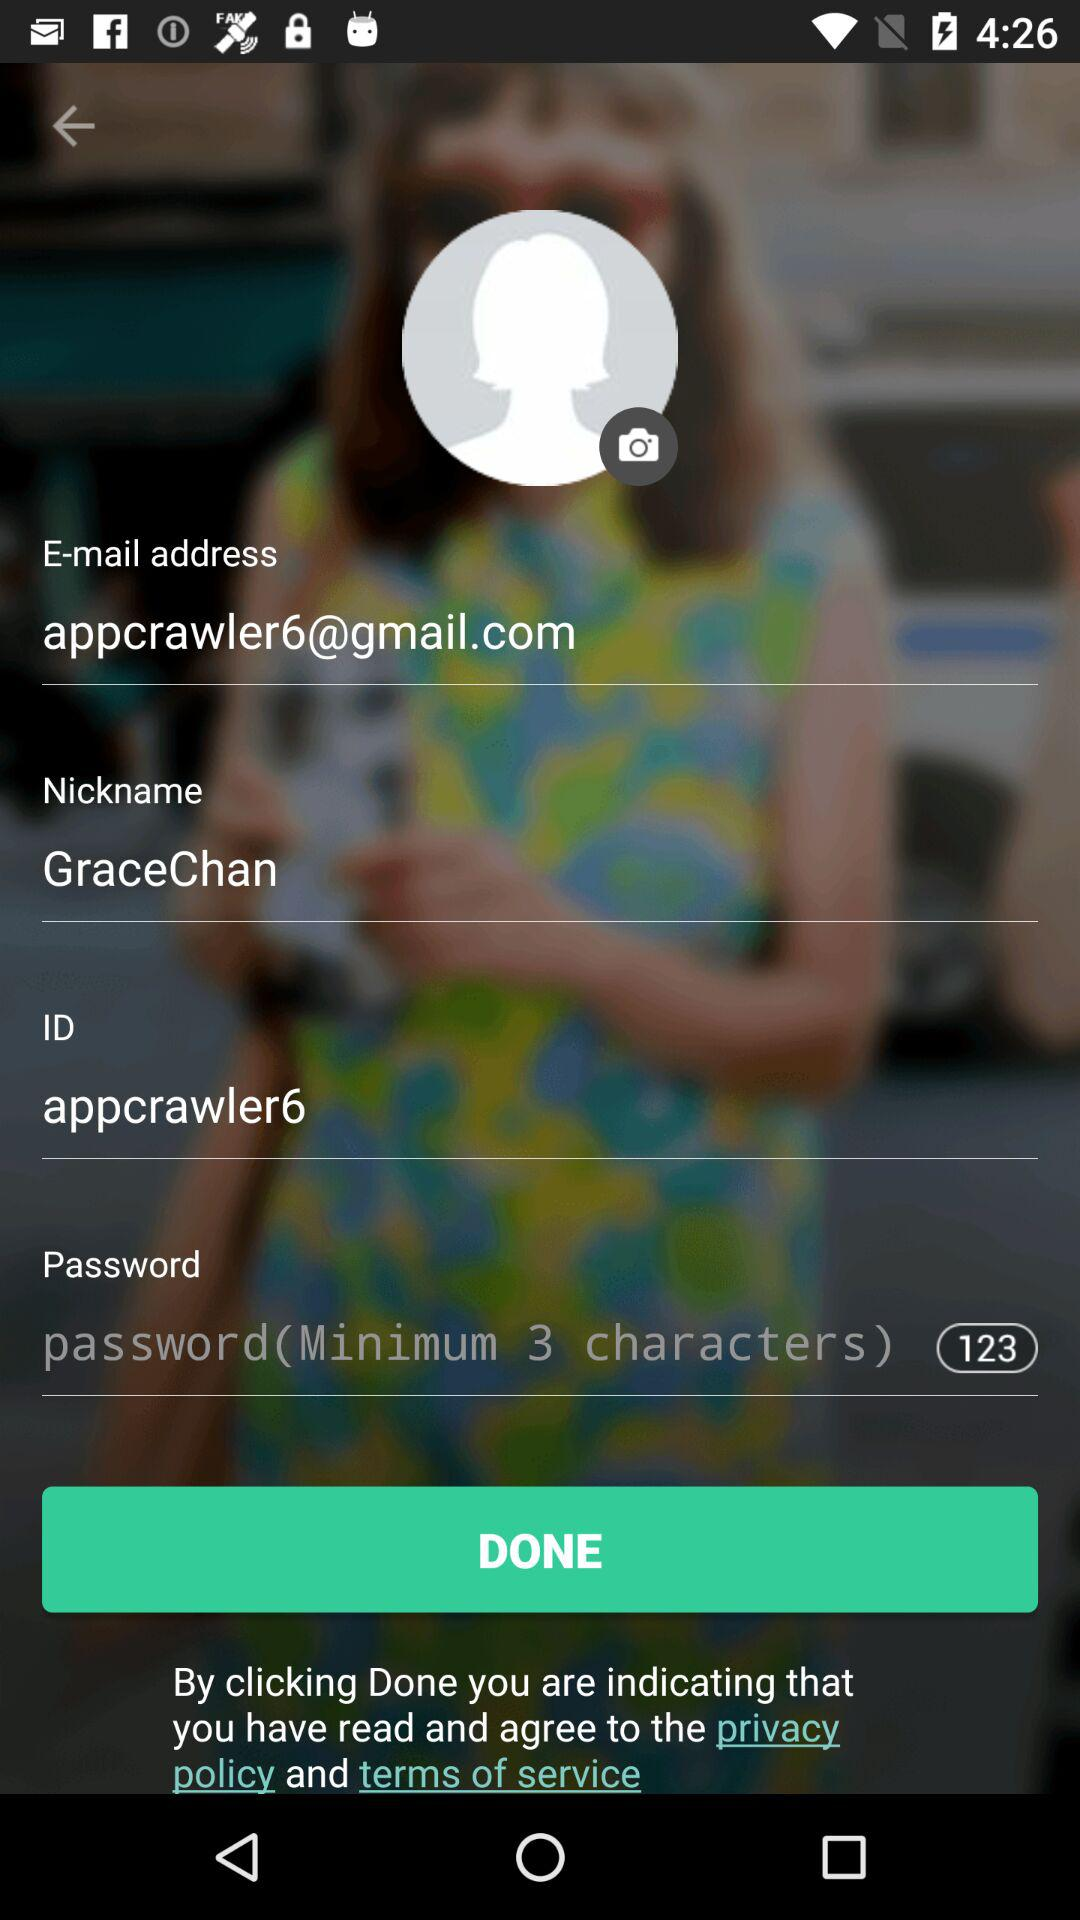What's the minimum character limit for the password? The minimum character limit for the password is 3. 